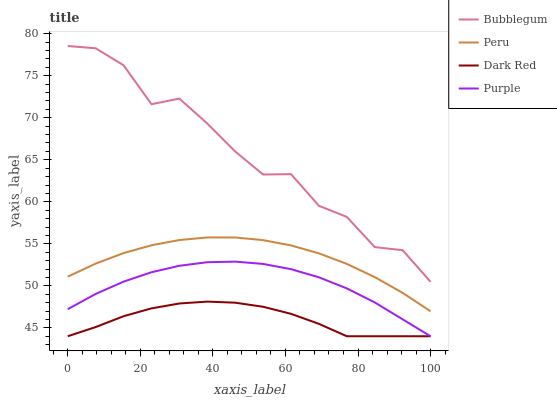Does Dark Red have the minimum area under the curve?
Answer yes or no. Yes. Does Bubblegum have the maximum area under the curve?
Answer yes or no. Yes. Does Peru have the minimum area under the curve?
Answer yes or no. No. Does Peru have the maximum area under the curve?
Answer yes or no. No. Is Peru the smoothest?
Answer yes or no. Yes. Is Bubblegum the roughest?
Answer yes or no. Yes. Is Dark Red the smoothest?
Answer yes or no. No. Is Dark Red the roughest?
Answer yes or no. No. Does Purple have the lowest value?
Answer yes or no. Yes. Does Peru have the lowest value?
Answer yes or no. No. Does Bubblegum have the highest value?
Answer yes or no. Yes. Does Peru have the highest value?
Answer yes or no. No. Is Dark Red less than Peru?
Answer yes or no. Yes. Is Bubblegum greater than Peru?
Answer yes or no. Yes. Does Dark Red intersect Purple?
Answer yes or no. Yes. Is Dark Red less than Purple?
Answer yes or no. No. Is Dark Red greater than Purple?
Answer yes or no. No. Does Dark Red intersect Peru?
Answer yes or no. No. 